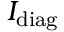Convert formula to latex. <formula><loc_0><loc_0><loc_500><loc_500>I _ { d i a g }</formula> 